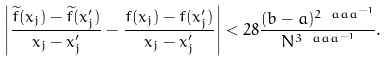Convert formula to latex. <formula><loc_0><loc_0><loc_500><loc_500>\left | \frac { { \widetilde { f } } ( x _ { j } ) - { \widetilde { f } } ( x _ { j } ^ { \prime } ) } { x _ { j } - x _ { j } ^ { \prime } } - \frac { f ( x _ { j } ) - f ( x _ { j } ^ { \prime } ) } { x _ { j } - x _ { j } ^ { \prime } } \right | < 2 8 \frac { ( b - a ) ^ { 2 \ a a a ^ { - 1 } } } { N ^ { 3 \ a a a ^ { - 1 } } } .</formula> 